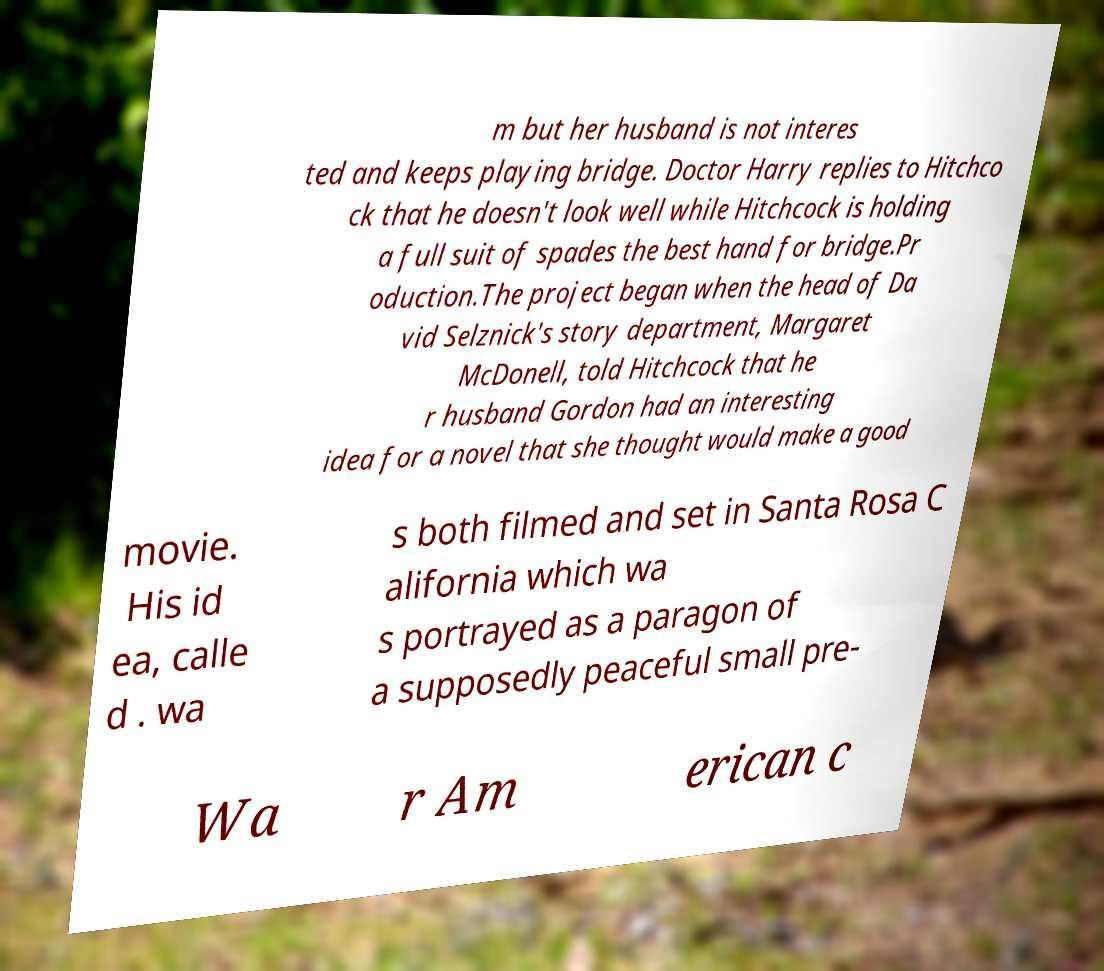Could you extract and type out the text from this image? m but her husband is not interes ted and keeps playing bridge. Doctor Harry replies to Hitchco ck that he doesn't look well while Hitchcock is holding a full suit of spades the best hand for bridge.Pr oduction.The project began when the head of Da vid Selznick's story department, Margaret McDonell, told Hitchcock that he r husband Gordon had an interesting idea for a novel that she thought would make a good movie. His id ea, calle d . wa s both filmed and set in Santa Rosa C alifornia which wa s portrayed as a paragon of a supposedly peaceful small pre- Wa r Am erican c 